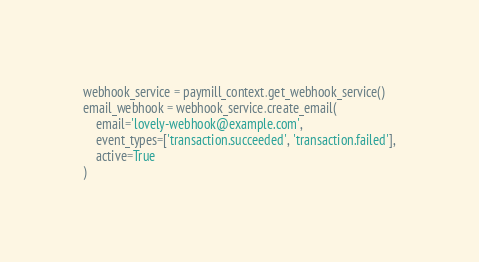<code> <loc_0><loc_0><loc_500><loc_500><_Python_>webhook_service = paymill_context.get_webhook_service()
email_webhook = webhook_service.create_email(
    email='lovely-webhook@example.com',
    event_types=['transaction.succeeded', 'transaction.failed'],
    active=True
)
</code> 